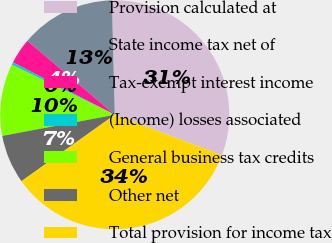Convert chart. <chart><loc_0><loc_0><loc_500><loc_500><pie_chart><fcel>Provision calculated at<fcel>State income tax net of<fcel>Tax-exempt interest income<fcel>(Income) losses associated<fcel>General business tax credits<fcel>Other net<fcel>Total provision for income tax<nl><fcel>31.15%<fcel>13.42%<fcel>3.62%<fcel>0.36%<fcel>10.15%<fcel>6.89%<fcel>34.41%<nl></chart> 